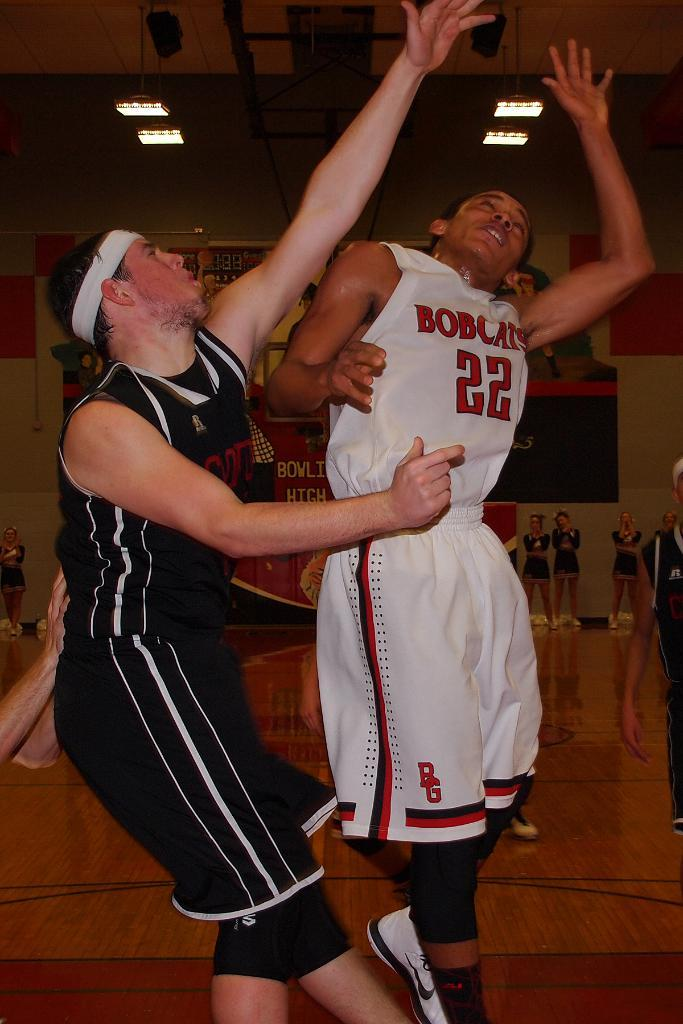<image>
Present a compact description of the photo's key features. A basketball game is underway and one of their uniforms says Bobcats 22. 